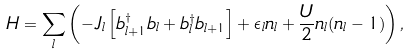<formula> <loc_0><loc_0><loc_500><loc_500>H = \sum _ { l } \left ( - J _ { l } \left [ b ^ { \dagger } _ { l + 1 } b _ { l } + b ^ { \dagger } _ { l } b _ { l + 1 } \right ] + \epsilon _ { l } n _ { l } + \frac { U } { 2 } n _ { l } ( n _ { l } - 1 ) \right ) ,</formula> 